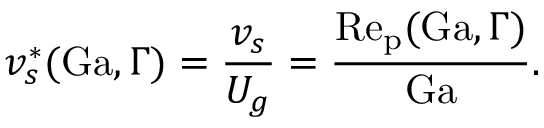<formula> <loc_0><loc_0><loc_500><loc_500>v _ { s } ^ { \ast } ( G a , \Gamma ) = \frac { v _ { s } } { U _ { g } } = \frac { R e _ { p } ( G a , \Gamma ) } { G a } .</formula> 